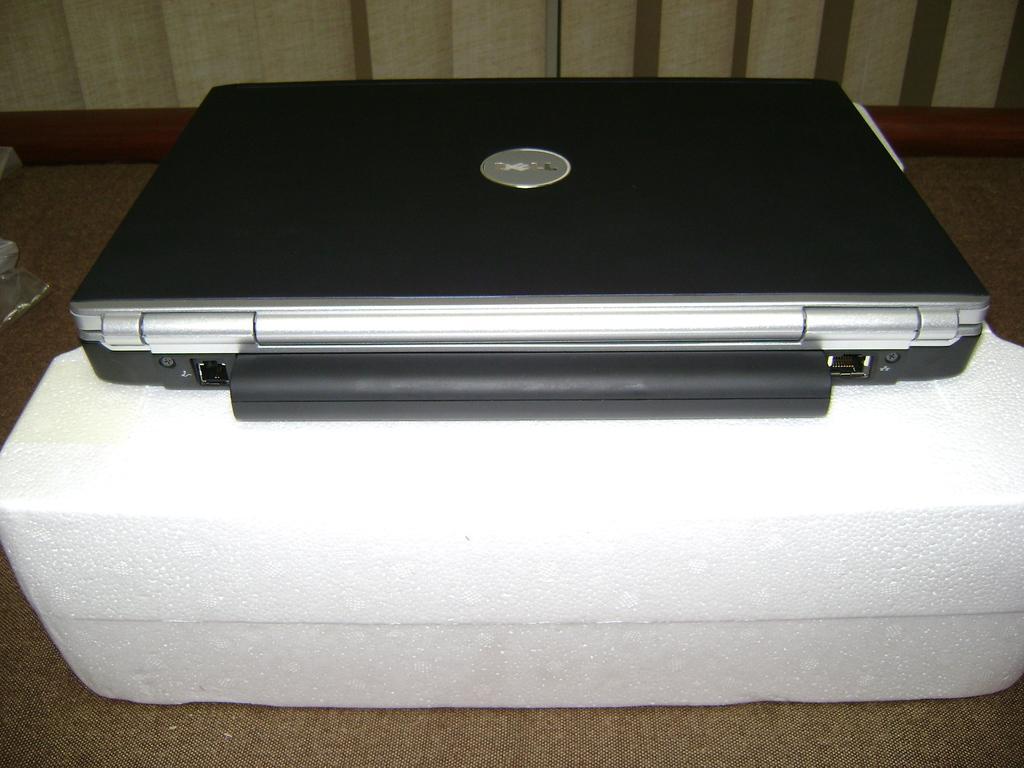In one or two sentences, can you explain what this image depicts? In this picture there is a netbook in the center of the image, on a polystyrene in the image. 